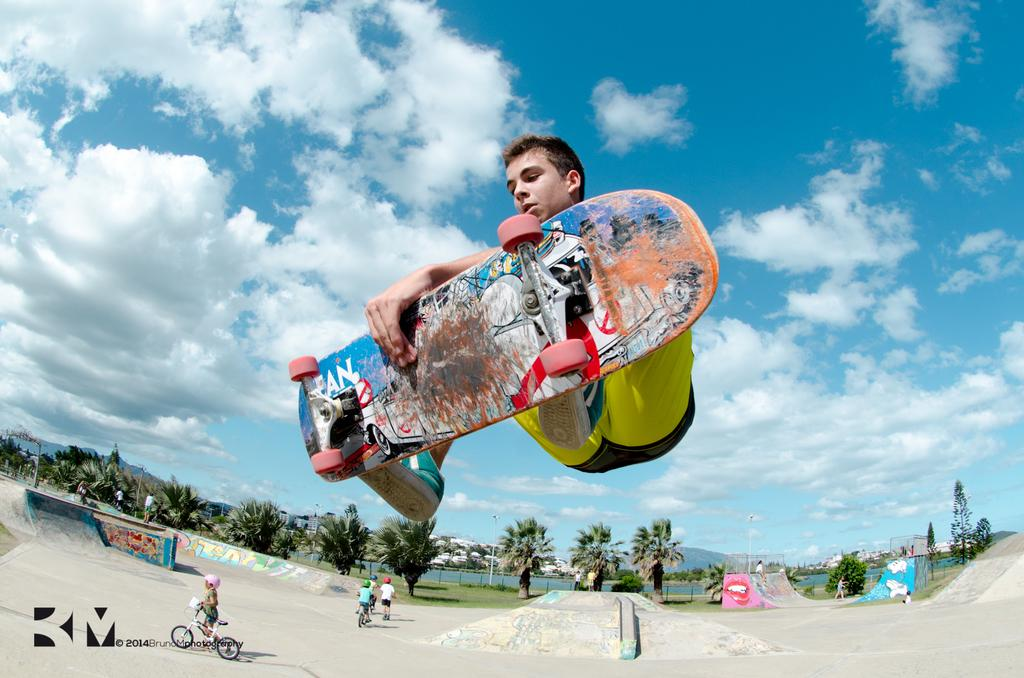What is the main subject of the image? There is a person in the image. What is the person doing in the image? The person is jumping with a skateboard. What can be seen in the background of the image? There are people in the background riding bicycles, a ramp, trees, and the sky. Where is the chalk used by the person in the image? There is no chalk present in the image. Can you describe the toad's behavior during the recess in the image? There is no toad or recess present in the image. 